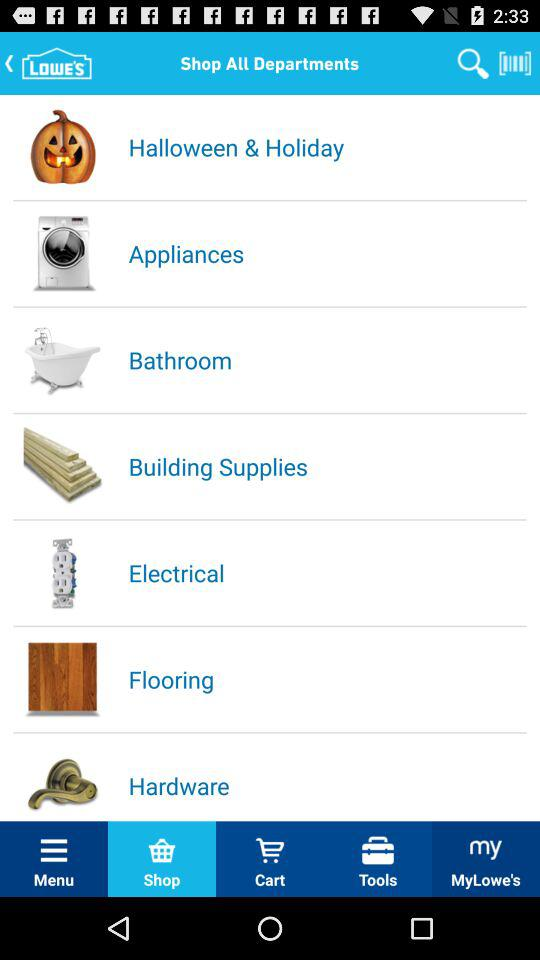Which tab is open? The open tab is "Shop". 